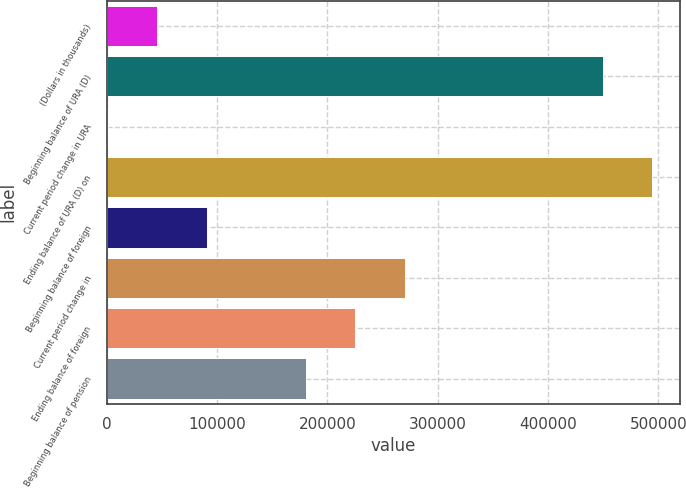Convert chart to OTSL. <chart><loc_0><loc_0><loc_500><loc_500><bar_chart><fcel>(Dollars in thousands)<fcel>Beginning balance of URA (D)<fcel>Current period change in URA<fcel>Ending balance of URA (D) on<fcel>Beginning balance of foreign<fcel>Current period change in<fcel>Ending balance of foreign<fcel>Beginning balance of pension<nl><fcel>45758.9<fcel>449579<fcel>890<fcel>494448<fcel>90627.8<fcel>270103<fcel>225234<fcel>180366<nl></chart> 